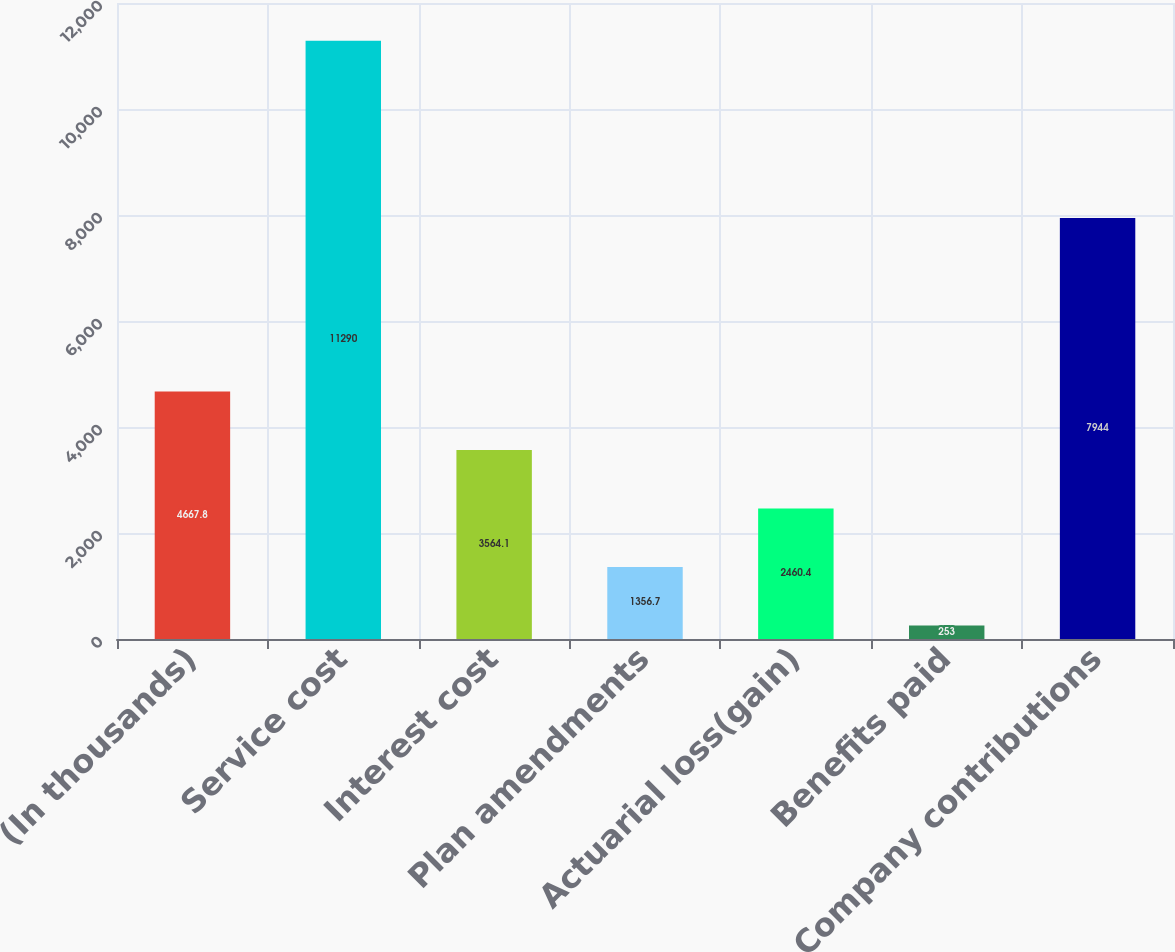<chart> <loc_0><loc_0><loc_500><loc_500><bar_chart><fcel>(In thousands)<fcel>Service cost<fcel>Interest cost<fcel>Plan amendments<fcel>Actuarial loss(gain)<fcel>Benefits paid<fcel>Company contributions<nl><fcel>4667.8<fcel>11290<fcel>3564.1<fcel>1356.7<fcel>2460.4<fcel>253<fcel>7944<nl></chart> 